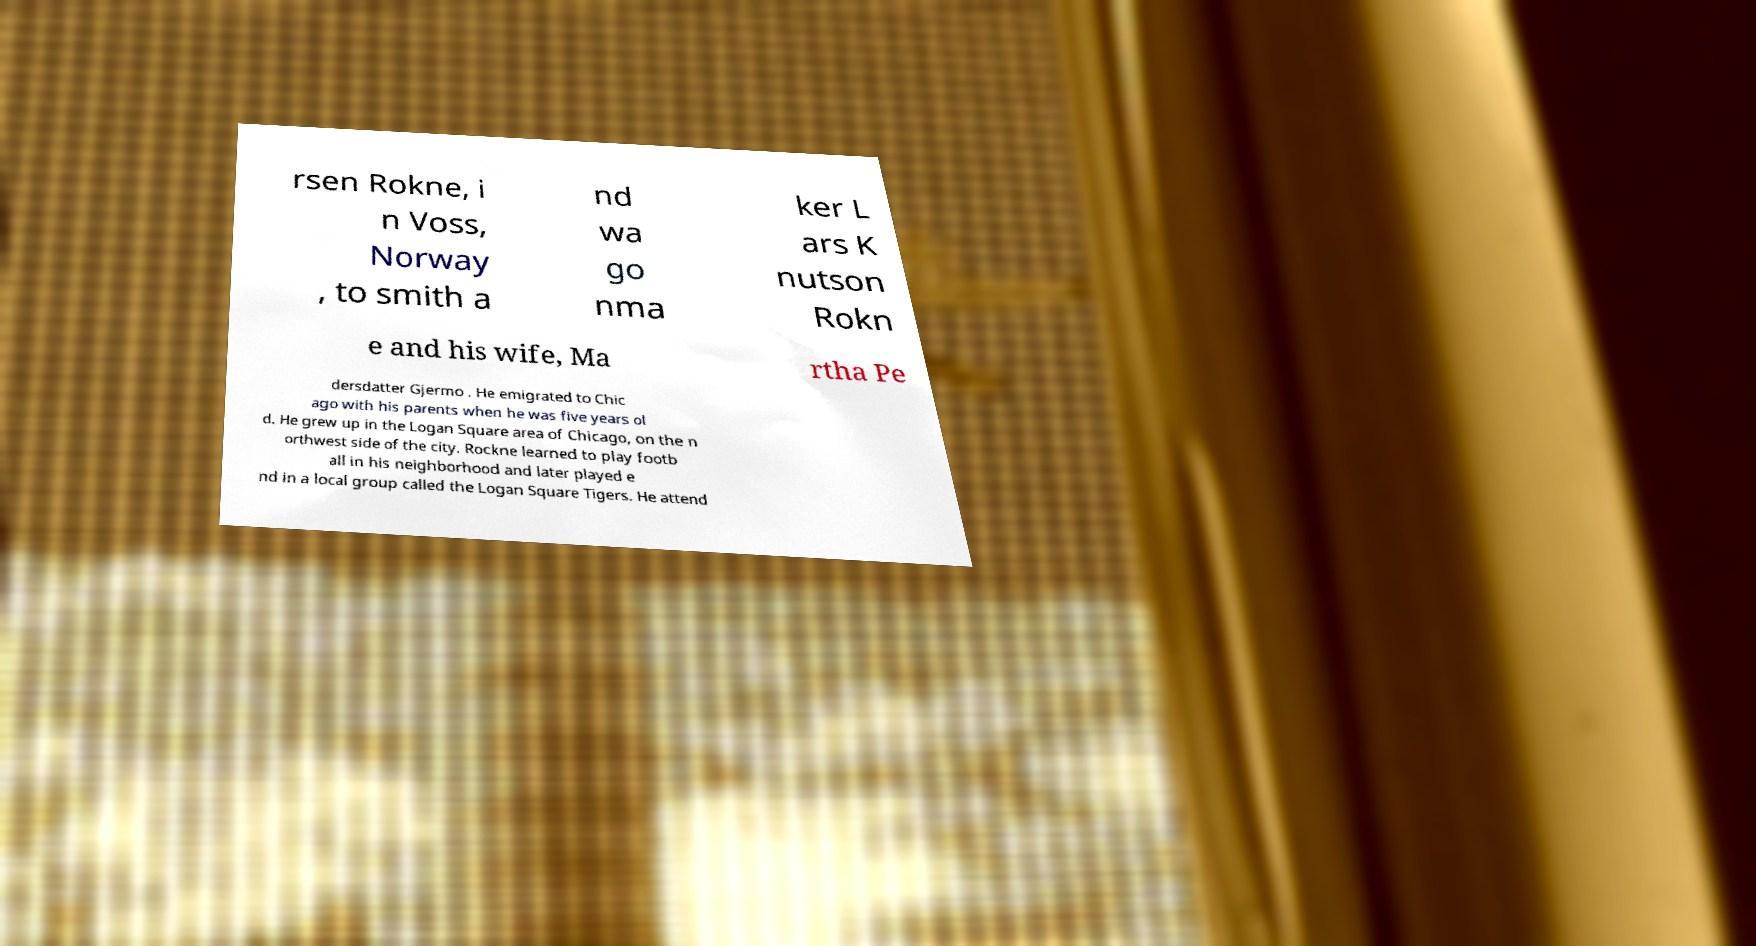Could you assist in decoding the text presented in this image and type it out clearly? rsen Rokne, i n Voss, Norway , to smith a nd wa go nma ker L ars K nutson Rokn e and his wife, Ma rtha Pe dersdatter Gjermo . He emigrated to Chic ago with his parents when he was five years ol d. He grew up in the Logan Square area of Chicago, on the n orthwest side of the city. Rockne learned to play footb all in his neighborhood and later played e nd in a local group called the Logan Square Tigers. He attend 